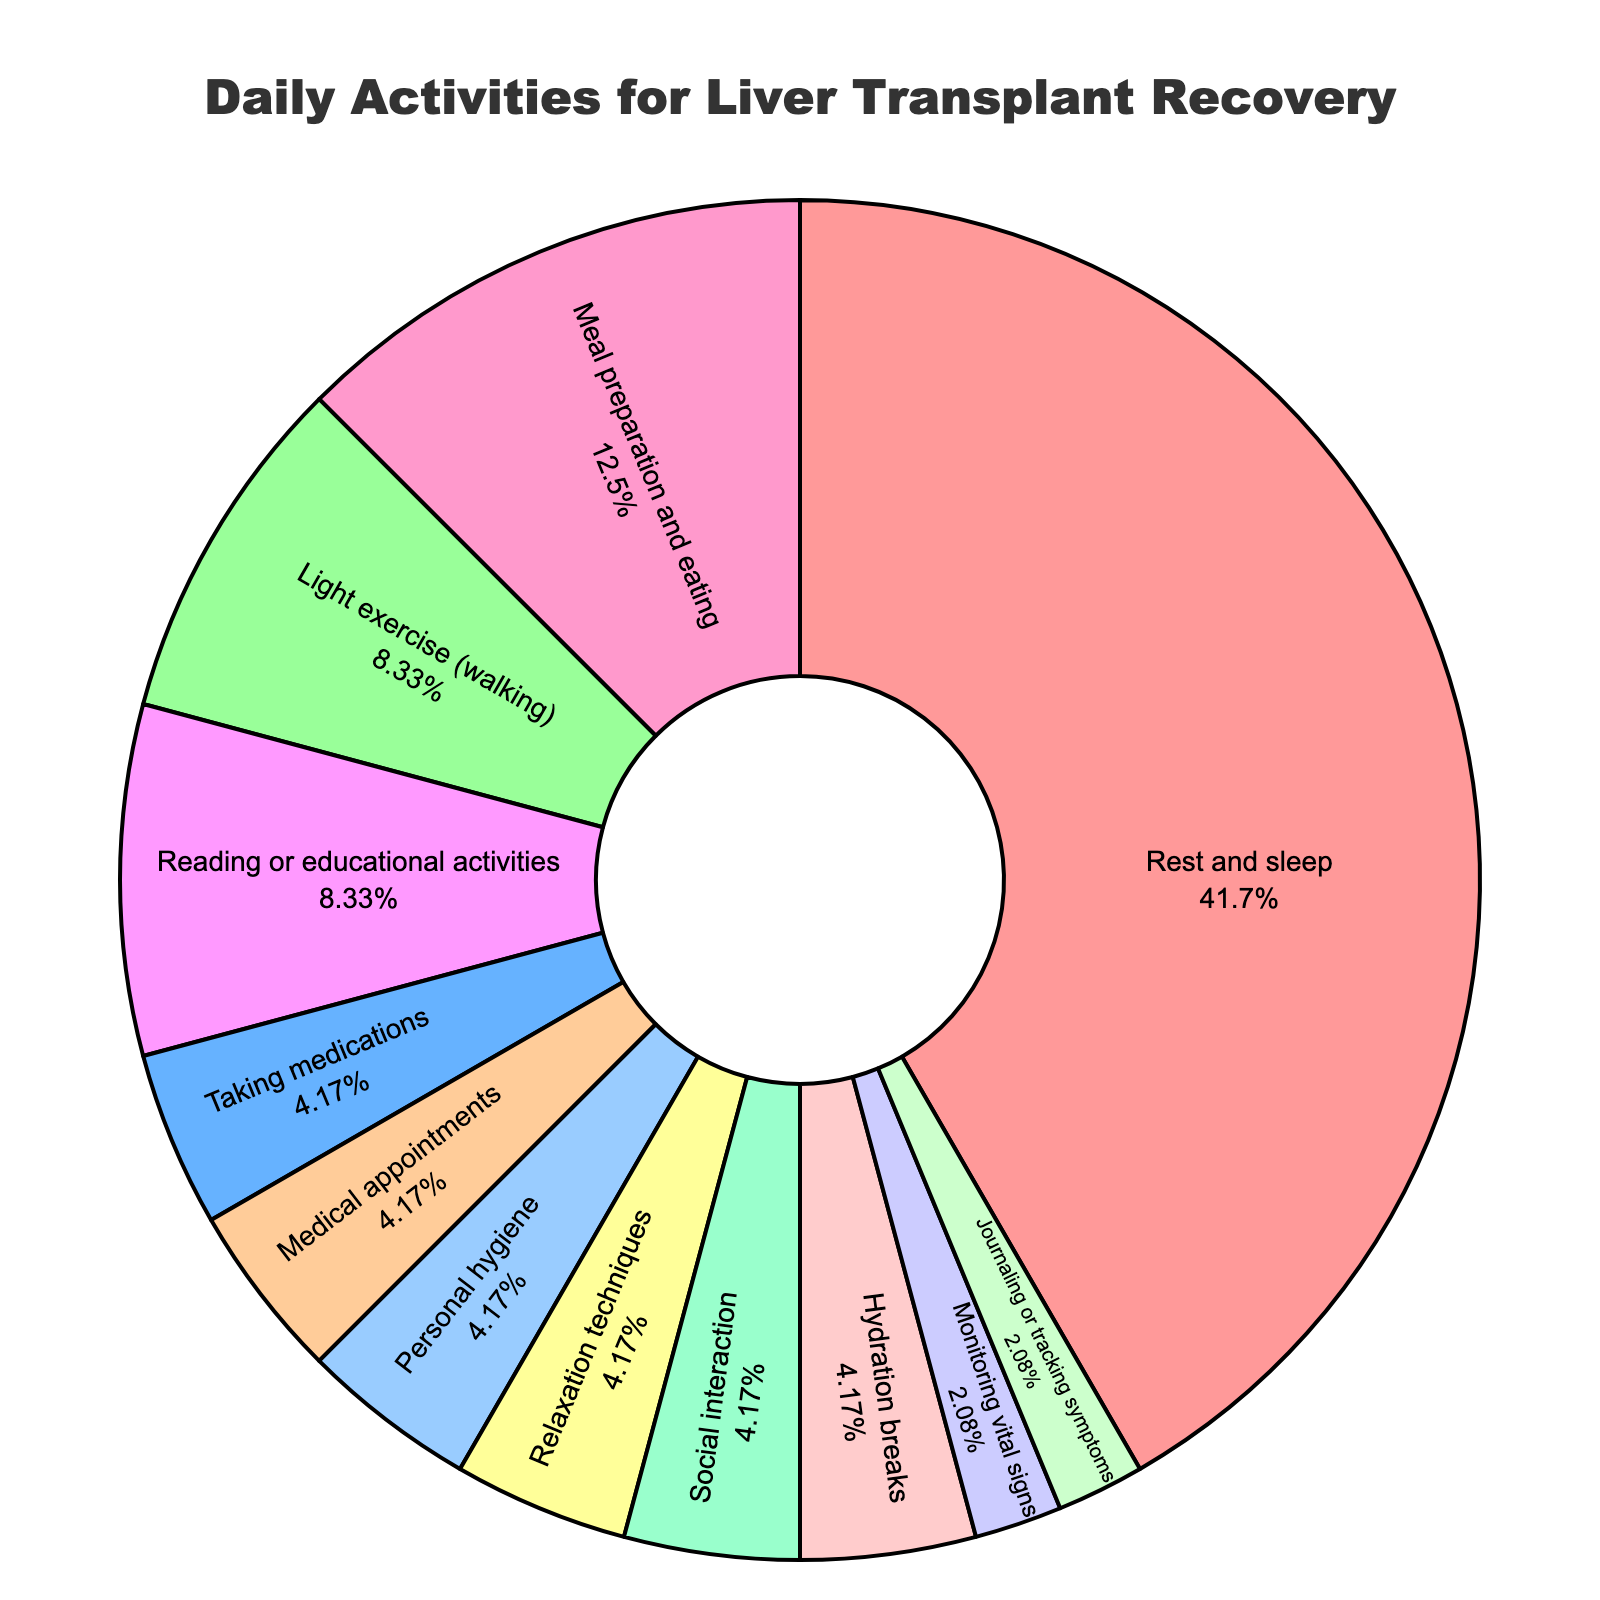What activity takes up the most time? From the pie chart, "Rest and sleep" is the largest segment, taking up the most space visually.
Answer: Rest and sleep Which two activities take up an equal amount of time? By looking at the pie chart segments, "Medical appointments" and "Personal hygiene" both occupy the same proportion of the chart.
Answer: Medical appointments and Personal hygiene How many hours are dedicated to activities related directly to health monitoring and symptoms? Summing the hours for "Monitoring vital signs" and "Journaling or tracking symptoms" gives us 0.5 + 0.5 = 1 hour.
Answer: 1 hour How much time is spent on physical activities? Adding the hours for "Light exercise (walking)" and "Relaxation techniques" yields 2 + 1 = 3 hours.
Answer: 3 hours Which activity is given slightly more time than "Social interaction" and how many more hours is it? "Hydration breaks" are given slightly more time than "Social interaction". "Hydration breaks" have 1 hour while "Social interaction" has 1 hour—both are equal, so the difference is 0 hours.
Answer: Hydration breaks, 0 hours Compare the time spent on "Meal preparation and eating" and "Reading or educational activities". The pie chart shows that "Meal preparation and eating" takes 3 hours, while "Reading or educational activities" takes 2 hours, so "Meal preparation and eating" takes 1 more hour.
Answer: Meal preparation and eating takes 1 more hour What percentage of the day is spent on "Meal preparation and eating"? The total number of hours is 24. "Meal preparation and eating" takes 3 hours. The percentage is (3/24) * 100 = 12.5%.
Answer: 12.5% Which activities combined make up half of the daily schedule? Adding the hours for "Rest and sleep" (10), "Meal preparation and eating" (3), "Light exercise (walking)" (2), and "Reading or educational activities" (2) gives 10 + 3 + 2 + 2 = 17 hours, which is more than half. Instead, adding "Rest and sleep" (10), "Meal preparation and eating" (3), and "Light exercise (walking)" (2) gives 10 + 3 + 2 = 15 hours, which is slightly less than half. Thus, there isn't an exact combination making up half.
Answer: No exact combination makes up half 